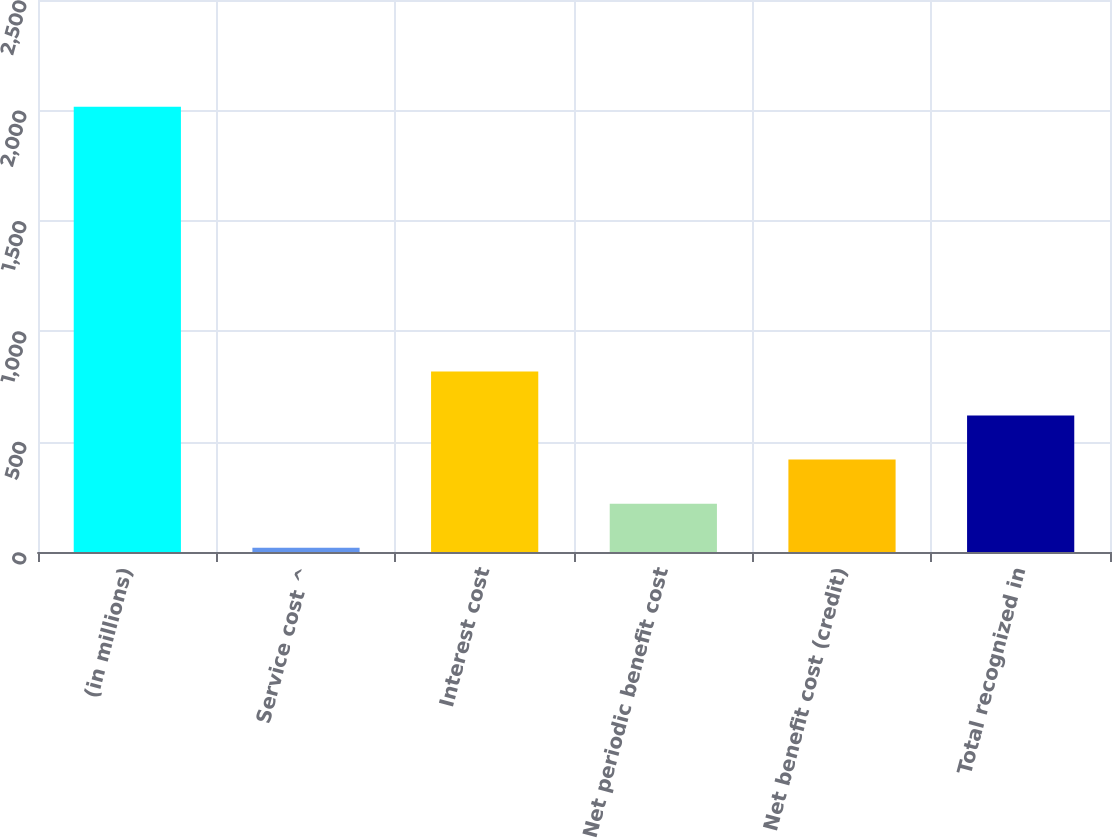<chart> <loc_0><loc_0><loc_500><loc_500><bar_chart><fcel>(in millions)<fcel>Service cost ^<fcel>Interest cost<fcel>Net periodic benefit cost<fcel>Net benefit cost (credit)<fcel>Total recognized in<nl><fcel>2016<fcel>19<fcel>817.8<fcel>218.7<fcel>418.4<fcel>618.1<nl></chart> 